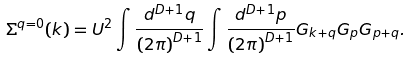<formula> <loc_0><loc_0><loc_500><loc_500>\Sigma ^ { q = 0 } ( k ) = U ^ { 2 } \int \frac { d ^ { D + 1 } q } { \left ( 2 \pi \right ) ^ { D + 1 } } \int \frac { d ^ { D + 1 } p } { \left ( 2 \pi \right ) ^ { D + 1 } } G _ { k + q } G _ { p } G _ { p + q } .</formula> 